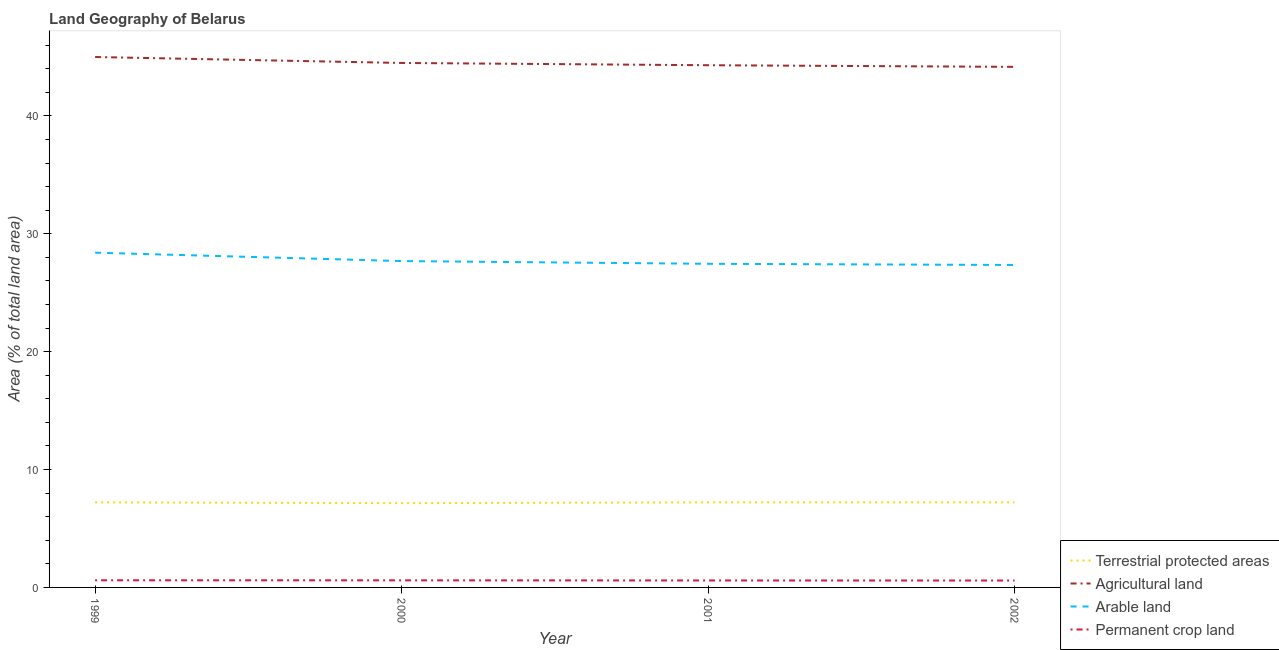Does the line corresponding to percentage of area under permanent crop land intersect with the line corresponding to percentage of area under agricultural land?
Provide a short and direct response. No. What is the percentage of area under arable land in 2002?
Your answer should be compact. 27.36. Across all years, what is the maximum percentage of area under agricultural land?
Ensure brevity in your answer.  45. Across all years, what is the minimum percentage of area under arable land?
Give a very brief answer. 27.36. In which year was the percentage of area under permanent crop land minimum?
Offer a very short reply. 2002. What is the total percentage of land under terrestrial protection in the graph?
Your answer should be very brief. 28.81. What is the difference between the percentage of area under agricultural land in 2000 and that in 2002?
Keep it short and to the point. 0.33. What is the difference between the percentage of area under permanent crop land in 2002 and the percentage of area under arable land in 1999?
Your answer should be very brief. -27.81. What is the average percentage of area under permanent crop land per year?
Your answer should be very brief. 0.6. In the year 1999, what is the difference between the percentage of area under agricultural land and percentage of area under arable land?
Your answer should be compact. 16.6. In how many years, is the percentage of land under terrestrial protection greater than 32 %?
Offer a terse response. 0. What is the ratio of the percentage of area under arable land in 2000 to that in 2001?
Provide a succinct answer. 1.01. Is the percentage of area under permanent crop land in 2000 less than that in 2001?
Offer a terse response. No. Is the difference between the percentage of area under agricultural land in 2001 and 2002 greater than the difference between the percentage of land under terrestrial protection in 2001 and 2002?
Give a very brief answer. Yes. What is the difference between the highest and the lowest percentage of land under terrestrial protection?
Ensure brevity in your answer.  0.07. In how many years, is the percentage of land under terrestrial protection greater than the average percentage of land under terrestrial protection taken over all years?
Your answer should be very brief. 3. Does the percentage of area under arable land monotonically increase over the years?
Your response must be concise. No. Is the percentage of land under terrestrial protection strictly greater than the percentage of area under permanent crop land over the years?
Offer a terse response. Yes. How many lines are there?
Make the answer very short. 4. Does the graph contain any zero values?
Provide a short and direct response. No. Does the graph contain grids?
Give a very brief answer. No. How many legend labels are there?
Keep it short and to the point. 4. How are the legend labels stacked?
Offer a very short reply. Vertical. What is the title of the graph?
Ensure brevity in your answer.  Land Geography of Belarus. Does "Ease of arranging shipments" appear as one of the legend labels in the graph?
Offer a very short reply. No. What is the label or title of the X-axis?
Your answer should be very brief. Year. What is the label or title of the Y-axis?
Make the answer very short. Area (% of total land area). What is the Area (% of total land area) in Terrestrial protected areas in 1999?
Offer a very short reply. 7.22. What is the Area (% of total land area) in Agricultural land in 1999?
Provide a succinct answer. 45. What is the Area (% of total land area) in Arable land in 1999?
Your answer should be very brief. 28.4. What is the Area (% of total land area) in Permanent crop land in 1999?
Keep it short and to the point. 0.61. What is the Area (% of total land area) of Terrestrial protected areas in 2000?
Keep it short and to the point. 7.15. What is the Area (% of total land area) of Agricultural land in 2000?
Your response must be concise. 44.5. What is the Area (% of total land area) of Arable land in 2000?
Your answer should be very brief. 27.69. What is the Area (% of total land area) in Permanent crop land in 2000?
Ensure brevity in your answer.  0.6. What is the Area (% of total land area) of Terrestrial protected areas in 2001?
Your answer should be very brief. 7.22. What is the Area (% of total land area) in Agricultural land in 2001?
Offer a very short reply. 44.3. What is the Area (% of total land area) of Arable land in 2001?
Your answer should be compact. 27.46. What is the Area (% of total land area) of Permanent crop land in 2001?
Keep it short and to the point. 0.59. What is the Area (% of total land area) of Terrestrial protected areas in 2002?
Provide a short and direct response. 7.22. What is the Area (% of total land area) in Agricultural land in 2002?
Ensure brevity in your answer.  44.16. What is the Area (% of total land area) of Arable land in 2002?
Give a very brief answer. 27.36. What is the Area (% of total land area) of Permanent crop land in 2002?
Give a very brief answer. 0.59. Across all years, what is the maximum Area (% of total land area) in Terrestrial protected areas?
Provide a succinct answer. 7.22. Across all years, what is the maximum Area (% of total land area) of Agricultural land?
Offer a terse response. 45. Across all years, what is the maximum Area (% of total land area) in Arable land?
Your response must be concise. 28.4. Across all years, what is the maximum Area (% of total land area) of Permanent crop land?
Make the answer very short. 0.61. Across all years, what is the minimum Area (% of total land area) in Terrestrial protected areas?
Make the answer very short. 7.15. Across all years, what is the minimum Area (% of total land area) in Agricultural land?
Make the answer very short. 44.16. Across all years, what is the minimum Area (% of total land area) of Arable land?
Keep it short and to the point. 27.36. Across all years, what is the minimum Area (% of total land area) of Permanent crop land?
Your answer should be very brief. 0.59. What is the total Area (% of total land area) in Terrestrial protected areas in the graph?
Keep it short and to the point. 28.81. What is the total Area (% of total land area) in Agricultural land in the graph?
Your response must be concise. 177.96. What is the total Area (% of total land area) of Arable land in the graph?
Offer a terse response. 110.9. What is the total Area (% of total land area) in Permanent crop land in the graph?
Give a very brief answer. 2.39. What is the difference between the Area (% of total land area) in Terrestrial protected areas in 1999 and that in 2000?
Offer a terse response. 0.07. What is the difference between the Area (% of total land area) of Agricultural land in 1999 and that in 2000?
Ensure brevity in your answer.  0.51. What is the difference between the Area (% of total land area) of Arable land in 1999 and that in 2000?
Offer a very short reply. 0.71. What is the difference between the Area (% of total land area) in Permanent crop land in 1999 and that in 2000?
Ensure brevity in your answer.  0. What is the difference between the Area (% of total land area) of Agricultural land in 1999 and that in 2001?
Provide a succinct answer. 0.7. What is the difference between the Area (% of total land area) of Arable land in 1999 and that in 2001?
Make the answer very short. 0.95. What is the difference between the Area (% of total land area) of Permanent crop land in 1999 and that in 2001?
Keep it short and to the point. 0.01. What is the difference between the Area (% of total land area) of Terrestrial protected areas in 1999 and that in 2002?
Provide a short and direct response. -0. What is the difference between the Area (% of total land area) of Agricultural land in 1999 and that in 2002?
Offer a terse response. 0.84. What is the difference between the Area (% of total land area) of Arable land in 1999 and that in 2002?
Offer a terse response. 1.05. What is the difference between the Area (% of total land area) of Permanent crop land in 1999 and that in 2002?
Keep it short and to the point. 0.02. What is the difference between the Area (% of total land area) in Terrestrial protected areas in 2000 and that in 2001?
Your answer should be very brief. -0.07. What is the difference between the Area (% of total land area) of Agricultural land in 2000 and that in 2001?
Provide a short and direct response. 0.19. What is the difference between the Area (% of total land area) of Arable land in 2000 and that in 2001?
Provide a succinct answer. 0.23. What is the difference between the Area (% of total land area) in Permanent crop land in 2000 and that in 2001?
Provide a succinct answer. 0.01. What is the difference between the Area (% of total land area) of Terrestrial protected areas in 2000 and that in 2002?
Provide a succinct answer. -0.07. What is the difference between the Area (% of total land area) of Agricultural land in 2000 and that in 2002?
Your answer should be compact. 0.33. What is the difference between the Area (% of total land area) in Arable land in 2000 and that in 2002?
Offer a very short reply. 0.33. What is the difference between the Area (% of total land area) in Permanent crop land in 2000 and that in 2002?
Give a very brief answer. 0.01. What is the difference between the Area (% of total land area) of Terrestrial protected areas in 2001 and that in 2002?
Keep it short and to the point. 0. What is the difference between the Area (% of total land area) in Agricultural land in 2001 and that in 2002?
Make the answer very short. 0.14. What is the difference between the Area (% of total land area) of Arable land in 2001 and that in 2002?
Your response must be concise. 0.1. What is the difference between the Area (% of total land area) in Permanent crop land in 2001 and that in 2002?
Offer a terse response. 0. What is the difference between the Area (% of total land area) of Terrestrial protected areas in 1999 and the Area (% of total land area) of Agricultural land in 2000?
Your response must be concise. -37.28. What is the difference between the Area (% of total land area) in Terrestrial protected areas in 1999 and the Area (% of total land area) in Arable land in 2000?
Provide a succinct answer. -20.47. What is the difference between the Area (% of total land area) in Terrestrial protected areas in 1999 and the Area (% of total land area) in Permanent crop land in 2000?
Provide a short and direct response. 6.62. What is the difference between the Area (% of total land area) of Agricultural land in 1999 and the Area (% of total land area) of Arable land in 2000?
Provide a short and direct response. 17.31. What is the difference between the Area (% of total land area) in Agricultural land in 1999 and the Area (% of total land area) in Permanent crop land in 2000?
Your response must be concise. 44.4. What is the difference between the Area (% of total land area) of Arable land in 1999 and the Area (% of total land area) of Permanent crop land in 2000?
Make the answer very short. 27.8. What is the difference between the Area (% of total land area) of Terrestrial protected areas in 1999 and the Area (% of total land area) of Agricultural land in 2001?
Provide a short and direct response. -37.08. What is the difference between the Area (% of total land area) of Terrestrial protected areas in 1999 and the Area (% of total land area) of Arable land in 2001?
Make the answer very short. -20.24. What is the difference between the Area (% of total land area) in Terrestrial protected areas in 1999 and the Area (% of total land area) in Permanent crop land in 2001?
Offer a terse response. 6.63. What is the difference between the Area (% of total land area) of Agricultural land in 1999 and the Area (% of total land area) of Arable land in 2001?
Keep it short and to the point. 17.54. What is the difference between the Area (% of total land area) of Agricultural land in 1999 and the Area (% of total land area) of Permanent crop land in 2001?
Give a very brief answer. 44.41. What is the difference between the Area (% of total land area) of Arable land in 1999 and the Area (% of total land area) of Permanent crop land in 2001?
Ensure brevity in your answer.  27.81. What is the difference between the Area (% of total land area) of Terrestrial protected areas in 1999 and the Area (% of total land area) of Agricultural land in 2002?
Your answer should be compact. -36.94. What is the difference between the Area (% of total land area) in Terrestrial protected areas in 1999 and the Area (% of total land area) in Arable land in 2002?
Your response must be concise. -20.14. What is the difference between the Area (% of total land area) of Terrestrial protected areas in 1999 and the Area (% of total land area) of Permanent crop land in 2002?
Your answer should be compact. 6.63. What is the difference between the Area (% of total land area) of Agricultural land in 1999 and the Area (% of total land area) of Arable land in 2002?
Ensure brevity in your answer.  17.65. What is the difference between the Area (% of total land area) in Agricultural land in 1999 and the Area (% of total land area) in Permanent crop land in 2002?
Ensure brevity in your answer.  44.41. What is the difference between the Area (% of total land area) in Arable land in 1999 and the Area (% of total land area) in Permanent crop land in 2002?
Provide a succinct answer. 27.81. What is the difference between the Area (% of total land area) in Terrestrial protected areas in 2000 and the Area (% of total land area) in Agricultural land in 2001?
Your answer should be compact. -37.16. What is the difference between the Area (% of total land area) of Terrestrial protected areas in 2000 and the Area (% of total land area) of Arable land in 2001?
Offer a very short reply. -20.31. What is the difference between the Area (% of total land area) of Terrestrial protected areas in 2000 and the Area (% of total land area) of Permanent crop land in 2001?
Your response must be concise. 6.56. What is the difference between the Area (% of total land area) of Agricultural land in 2000 and the Area (% of total land area) of Arable land in 2001?
Provide a succinct answer. 17.04. What is the difference between the Area (% of total land area) of Agricultural land in 2000 and the Area (% of total land area) of Permanent crop land in 2001?
Keep it short and to the point. 43.9. What is the difference between the Area (% of total land area) of Arable land in 2000 and the Area (% of total land area) of Permanent crop land in 2001?
Offer a very short reply. 27.1. What is the difference between the Area (% of total land area) in Terrestrial protected areas in 2000 and the Area (% of total land area) in Agricultural land in 2002?
Keep it short and to the point. -37.02. What is the difference between the Area (% of total land area) in Terrestrial protected areas in 2000 and the Area (% of total land area) in Arable land in 2002?
Offer a very short reply. -20.21. What is the difference between the Area (% of total land area) in Terrestrial protected areas in 2000 and the Area (% of total land area) in Permanent crop land in 2002?
Give a very brief answer. 6.56. What is the difference between the Area (% of total land area) in Agricultural land in 2000 and the Area (% of total land area) in Arable land in 2002?
Ensure brevity in your answer.  17.14. What is the difference between the Area (% of total land area) in Agricultural land in 2000 and the Area (% of total land area) in Permanent crop land in 2002?
Provide a short and direct response. 43.91. What is the difference between the Area (% of total land area) in Arable land in 2000 and the Area (% of total land area) in Permanent crop land in 2002?
Your answer should be compact. 27.1. What is the difference between the Area (% of total land area) of Terrestrial protected areas in 2001 and the Area (% of total land area) of Agricultural land in 2002?
Your response must be concise. -36.94. What is the difference between the Area (% of total land area) of Terrestrial protected areas in 2001 and the Area (% of total land area) of Arable land in 2002?
Ensure brevity in your answer.  -20.14. What is the difference between the Area (% of total land area) of Terrestrial protected areas in 2001 and the Area (% of total land area) of Permanent crop land in 2002?
Keep it short and to the point. 6.63. What is the difference between the Area (% of total land area) in Agricultural land in 2001 and the Area (% of total land area) in Arable land in 2002?
Offer a very short reply. 16.95. What is the difference between the Area (% of total land area) of Agricultural land in 2001 and the Area (% of total land area) of Permanent crop land in 2002?
Your answer should be very brief. 43.72. What is the difference between the Area (% of total land area) of Arable land in 2001 and the Area (% of total land area) of Permanent crop land in 2002?
Your answer should be very brief. 26.87. What is the average Area (% of total land area) of Terrestrial protected areas per year?
Make the answer very short. 7.2. What is the average Area (% of total land area) of Agricultural land per year?
Offer a very short reply. 44.49. What is the average Area (% of total land area) in Arable land per year?
Provide a succinct answer. 27.73. What is the average Area (% of total land area) in Permanent crop land per year?
Your answer should be compact. 0.6. In the year 1999, what is the difference between the Area (% of total land area) of Terrestrial protected areas and Area (% of total land area) of Agricultural land?
Your answer should be compact. -37.78. In the year 1999, what is the difference between the Area (% of total land area) of Terrestrial protected areas and Area (% of total land area) of Arable land?
Provide a succinct answer. -21.18. In the year 1999, what is the difference between the Area (% of total land area) in Terrestrial protected areas and Area (% of total land area) in Permanent crop land?
Offer a terse response. 6.61. In the year 1999, what is the difference between the Area (% of total land area) of Agricultural land and Area (% of total land area) of Arable land?
Make the answer very short. 16.6. In the year 1999, what is the difference between the Area (% of total land area) in Agricultural land and Area (% of total land area) in Permanent crop land?
Provide a succinct answer. 44.39. In the year 1999, what is the difference between the Area (% of total land area) of Arable land and Area (% of total land area) of Permanent crop land?
Provide a succinct answer. 27.8. In the year 2000, what is the difference between the Area (% of total land area) of Terrestrial protected areas and Area (% of total land area) of Agricultural land?
Ensure brevity in your answer.  -37.35. In the year 2000, what is the difference between the Area (% of total land area) of Terrestrial protected areas and Area (% of total land area) of Arable land?
Provide a short and direct response. -20.54. In the year 2000, what is the difference between the Area (% of total land area) in Terrestrial protected areas and Area (% of total land area) in Permanent crop land?
Your response must be concise. 6.55. In the year 2000, what is the difference between the Area (% of total land area) in Agricultural land and Area (% of total land area) in Arable land?
Provide a succinct answer. 16.81. In the year 2000, what is the difference between the Area (% of total land area) in Agricultural land and Area (% of total land area) in Permanent crop land?
Offer a very short reply. 43.89. In the year 2000, what is the difference between the Area (% of total land area) in Arable land and Area (% of total land area) in Permanent crop land?
Offer a very short reply. 27.09. In the year 2001, what is the difference between the Area (% of total land area) of Terrestrial protected areas and Area (% of total land area) of Agricultural land?
Ensure brevity in your answer.  -37.08. In the year 2001, what is the difference between the Area (% of total land area) in Terrestrial protected areas and Area (% of total land area) in Arable land?
Offer a terse response. -20.24. In the year 2001, what is the difference between the Area (% of total land area) of Terrestrial protected areas and Area (% of total land area) of Permanent crop land?
Your answer should be very brief. 6.63. In the year 2001, what is the difference between the Area (% of total land area) of Agricultural land and Area (% of total land area) of Arable land?
Your response must be concise. 16.85. In the year 2001, what is the difference between the Area (% of total land area) in Agricultural land and Area (% of total land area) in Permanent crop land?
Your answer should be very brief. 43.71. In the year 2001, what is the difference between the Area (% of total land area) in Arable land and Area (% of total land area) in Permanent crop land?
Your answer should be compact. 26.86. In the year 2002, what is the difference between the Area (% of total land area) in Terrestrial protected areas and Area (% of total land area) in Agricultural land?
Provide a short and direct response. -36.94. In the year 2002, what is the difference between the Area (% of total land area) of Terrestrial protected areas and Area (% of total land area) of Arable land?
Provide a short and direct response. -20.14. In the year 2002, what is the difference between the Area (% of total land area) of Terrestrial protected areas and Area (% of total land area) of Permanent crop land?
Provide a short and direct response. 6.63. In the year 2002, what is the difference between the Area (% of total land area) in Agricultural land and Area (% of total land area) in Arable land?
Make the answer very short. 16.81. In the year 2002, what is the difference between the Area (% of total land area) in Agricultural land and Area (% of total land area) in Permanent crop land?
Ensure brevity in your answer.  43.58. In the year 2002, what is the difference between the Area (% of total land area) in Arable land and Area (% of total land area) in Permanent crop land?
Keep it short and to the point. 26.77. What is the ratio of the Area (% of total land area) in Agricultural land in 1999 to that in 2000?
Your response must be concise. 1.01. What is the ratio of the Area (% of total land area) in Arable land in 1999 to that in 2000?
Your answer should be compact. 1.03. What is the ratio of the Area (% of total land area) of Agricultural land in 1999 to that in 2001?
Offer a terse response. 1.02. What is the ratio of the Area (% of total land area) in Arable land in 1999 to that in 2001?
Your answer should be compact. 1.03. What is the ratio of the Area (% of total land area) in Permanent crop land in 1999 to that in 2001?
Your answer should be compact. 1.02. What is the ratio of the Area (% of total land area) in Agricultural land in 1999 to that in 2002?
Give a very brief answer. 1.02. What is the ratio of the Area (% of total land area) of Arable land in 1999 to that in 2002?
Keep it short and to the point. 1.04. What is the ratio of the Area (% of total land area) of Permanent crop land in 1999 to that in 2002?
Provide a short and direct response. 1.03. What is the ratio of the Area (% of total land area) in Terrestrial protected areas in 2000 to that in 2001?
Keep it short and to the point. 0.99. What is the ratio of the Area (% of total land area) in Arable land in 2000 to that in 2001?
Offer a very short reply. 1.01. What is the ratio of the Area (% of total land area) of Permanent crop land in 2000 to that in 2001?
Your response must be concise. 1.02. What is the ratio of the Area (% of total land area) in Agricultural land in 2000 to that in 2002?
Your answer should be very brief. 1.01. What is the ratio of the Area (% of total land area) of Arable land in 2000 to that in 2002?
Ensure brevity in your answer.  1.01. What is the ratio of the Area (% of total land area) in Permanent crop land in 2000 to that in 2002?
Give a very brief answer. 1.03. What is the ratio of the Area (% of total land area) of Terrestrial protected areas in 2001 to that in 2002?
Provide a short and direct response. 1. What is the ratio of the Area (% of total land area) of Permanent crop land in 2001 to that in 2002?
Your answer should be compact. 1.01. What is the difference between the highest and the second highest Area (% of total land area) of Terrestrial protected areas?
Your answer should be compact. 0. What is the difference between the highest and the second highest Area (% of total land area) of Agricultural land?
Make the answer very short. 0.51. What is the difference between the highest and the second highest Area (% of total land area) in Arable land?
Ensure brevity in your answer.  0.71. What is the difference between the highest and the second highest Area (% of total land area) in Permanent crop land?
Give a very brief answer. 0. What is the difference between the highest and the lowest Area (% of total land area) in Terrestrial protected areas?
Provide a short and direct response. 0.07. What is the difference between the highest and the lowest Area (% of total land area) in Agricultural land?
Offer a terse response. 0.84. What is the difference between the highest and the lowest Area (% of total land area) of Arable land?
Provide a short and direct response. 1.05. What is the difference between the highest and the lowest Area (% of total land area) of Permanent crop land?
Provide a succinct answer. 0.02. 